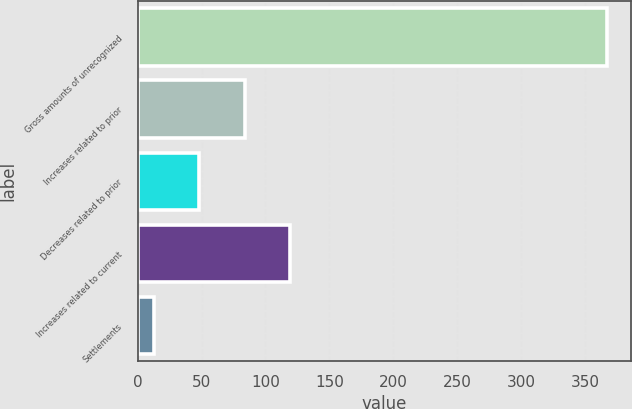Convert chart to OTSL. <chart><loc_0><loc_0><loc_500><loc_500><bar_chart><fcel>Gross amounts of unrecognized<fcel>Increases related to prior<fcel>Decreases related to prior<fcel>Increases related to current<fcel>Settlements<nl><fcel>367<fcel>83.8<fcel>48.4<fcel>119.2<fcel>13<nl></chart> 